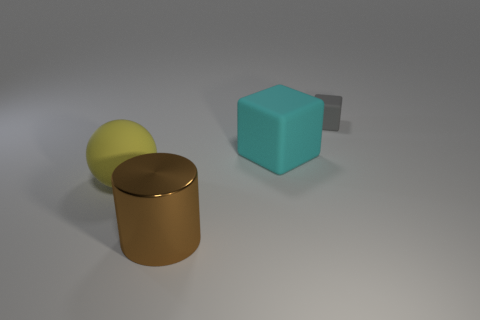Is there a large metallic ball of the same color as the matte sphere?
Offer a terse response. No. What is the color of the other metallic object that is the same size as the cyan object?
Make the answer very short. Brown. Are the thing left of the big cylinder and the small object made of the same material?
Ensure brevity in your answer.  Yes. Is there a big brown metal object to the left of the big matte thing to the right of the big rubber thing that is left of the big cube?
Offer a very short reply. Yes. Do the object that is behind the big cyan rubber object and the yellow object have the same shape?
Provide a succinct answer. No. There is a rubber object that is behind the large matte cube behind the sphere; what is its shape?
Your answer should be very brief. Cube. There is a object that is behind the large thing to the right of the object that is in front of the sphere; what is its size?
Keep it short and to the point. Small. There is another matte thing that is the same shape as the tiny gray matte thing; what color is it?
Ensure brevity in your answer.  Cyan. Is the size of the gray cube the same as the brown thing?
Your response must be concise. No. There is a cube that is in front of the tiny cube; what material is it?
Offer a very short reply. Rubber. 